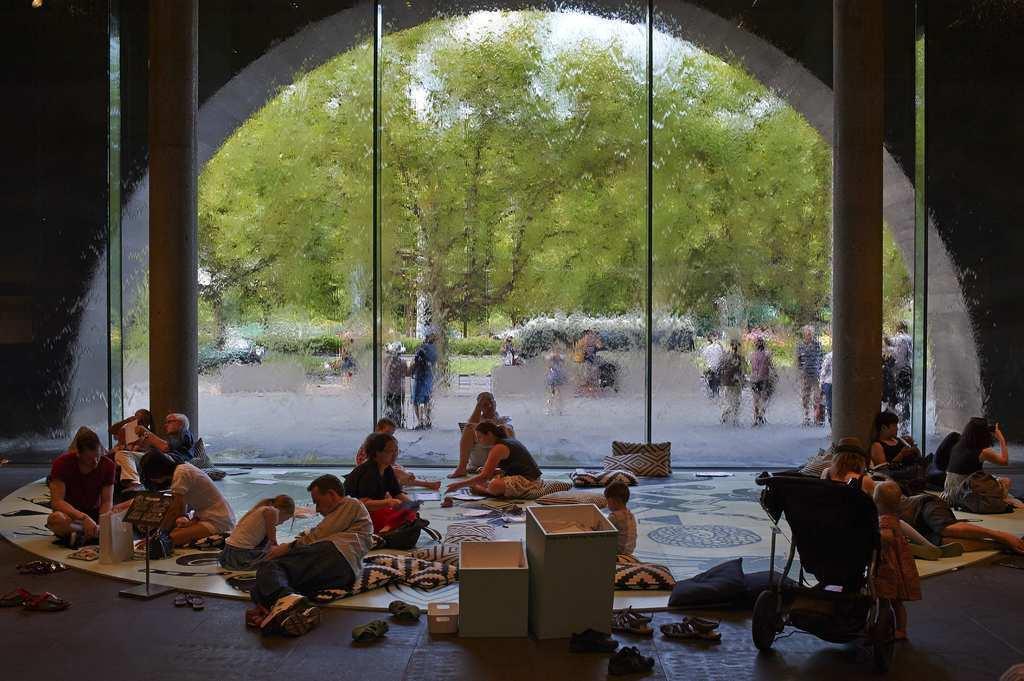In one or two sentences, can you explain what this image depicts? Here we can see few persons are sitting on the floor and few persons are lying on the floor. We can also see few boxes,a stroller,kid standing on the floor,In the background we can see glass wall and pillars. Through the glass we can see few persons and trees. 